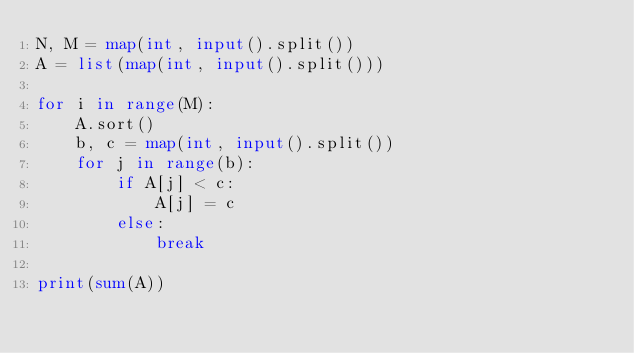Convert code to text. <code><loc_0><loc_0><loc_500><loc_500><_Python_>N, M = map(int, input().split())
A = list(map(int, input().split()))

for i in range(M):
    A.sort()
    b, c = map(int, input().split())
    for j in range(b):
        if A[j] < c:
            A[j] = c
        else:
            break

print(sum(A))
</code> 